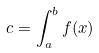Convert formula to latex. <formula><loc_0><loc_0><loc_500><loc_500>c = \int _ { a } ^ { b } f ( x )</formula> 